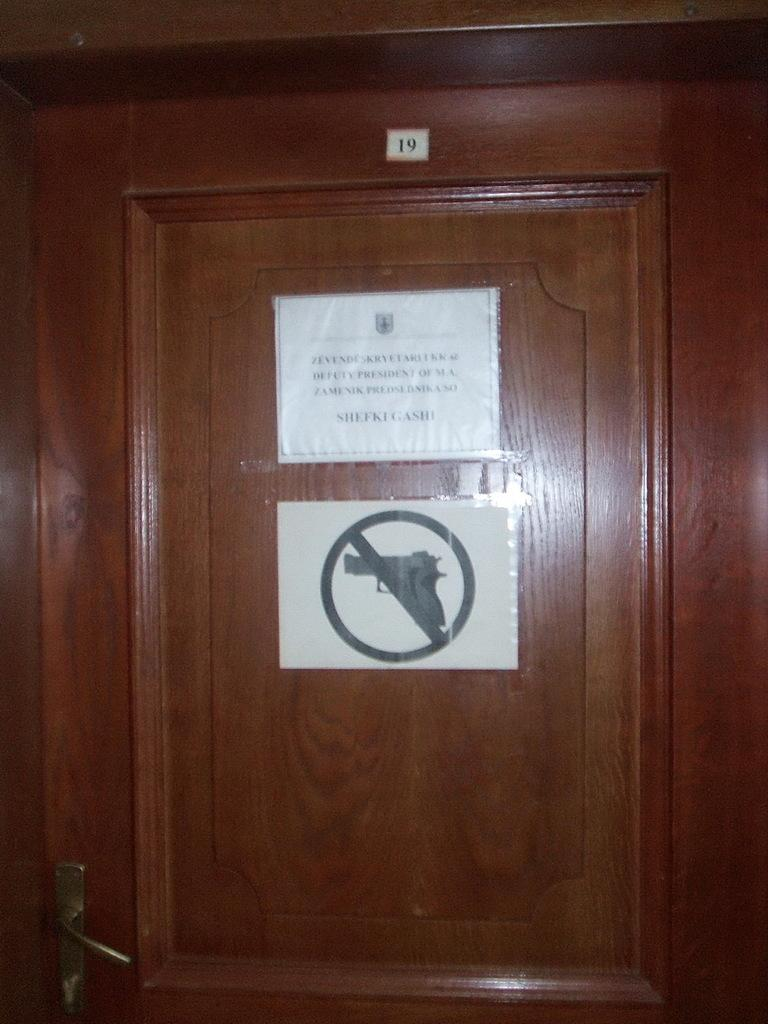What is attached to the door in the image? There are two papers attached to the door in the image. Can you describe the content of the papers? The provided facts do not mention the content of the papers, only that they do not have a gun sign on them. How does the duck in the image express its disgust? There is no duck present in the image, so it cannot express any emotions. 